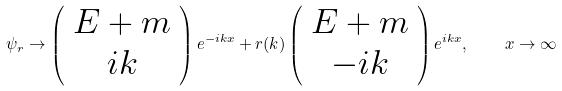<formula> <loc_0><loc_0><loc_500><loc_500>\psi _ { r } \to \left ( \begin{array} { c } E + m \\ i k \end{array} \right ) e ^ { - i k x } + r ( k ) \left ( \begin{array} { c } E + m \\ - i k \end{array} \right ) e ^ { i k x } , \quad x \to \infty</formula> 